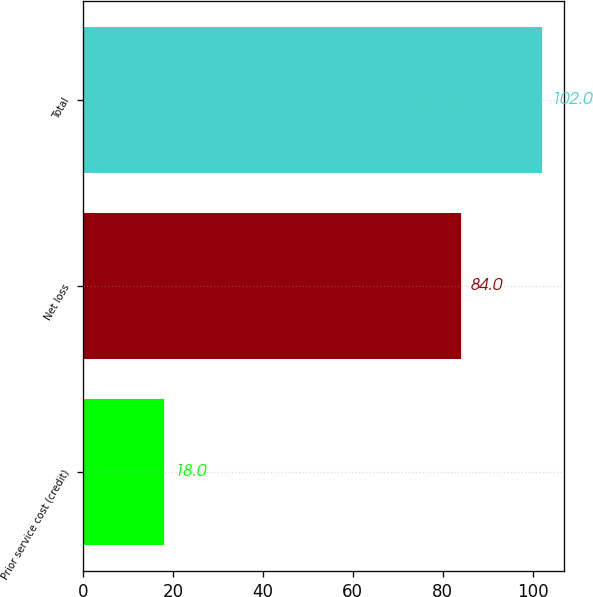Convert chart to OTSL. <chart><loc_0><loc_0><loc_500><loc_500><bar_chart><fcel>Prior service cost (credit)<fcel>Net loss<fcel>Total<nl><fcel>18<fcel>84<fcel>102<nl></chart> 